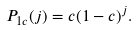Convert formula to latex. <formula><loc_0><loc_0><loc_500><loc_500>P _ { 1 c } ( j ) = c ( 1 - c ) ^ { j } .</formula> 